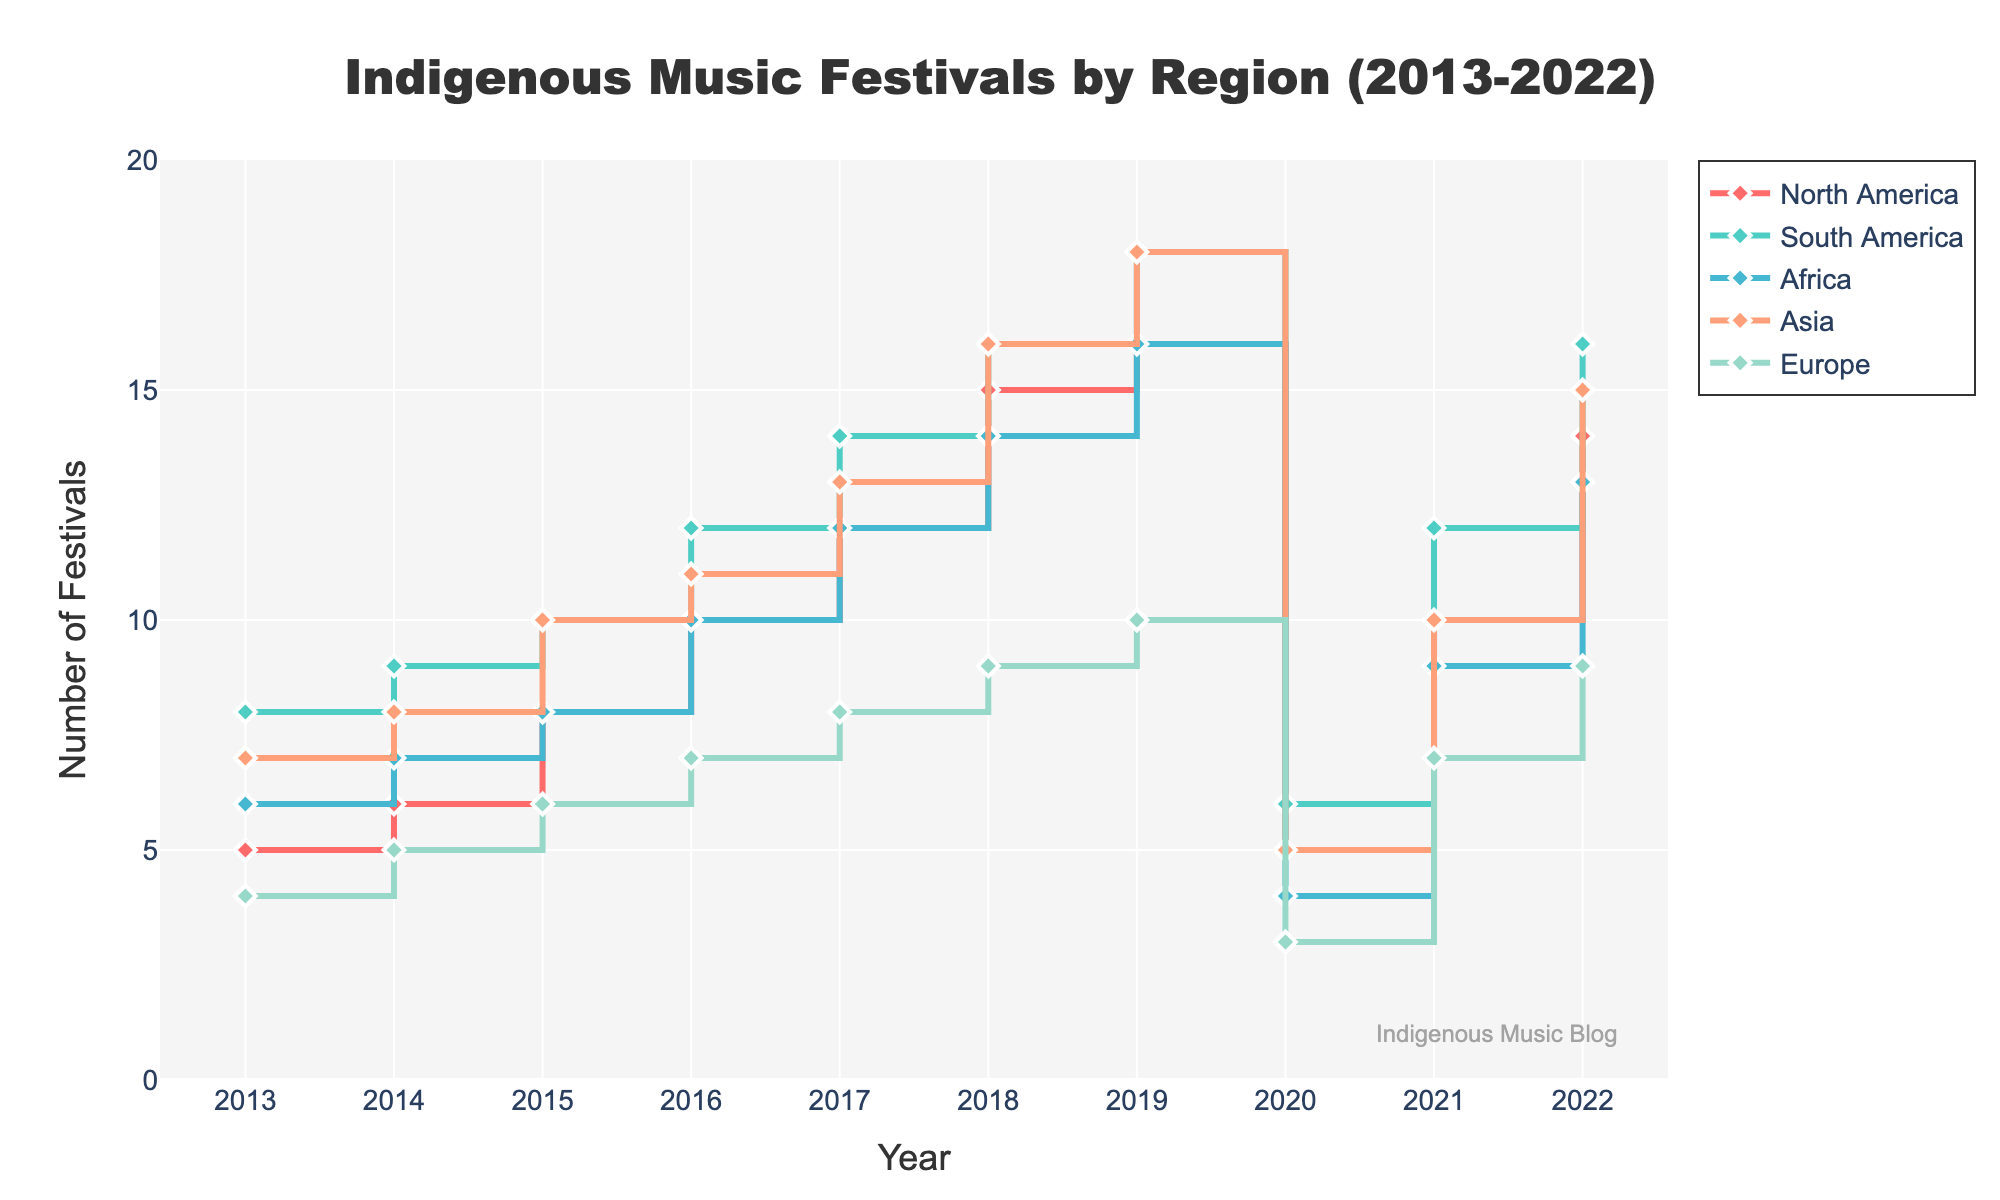Which region had the highest number of festivals in 2022? Look at the year 2022 on the x-axis and identify the highest point on the y-axis among all regions. South America reaches the highest value at 16 festivals.
Answer: South America How many festivals were held in Europe in 2020? Locate the year 2020 on the x-axis and check the corresponding value for the Europe region on the y-axis. The data point for Europe reads 3 festivals.
Answer: 3 What trend can be observed in the number of festivals in Asia from 2013 to 2019? Observe the data points for Asia from 2013 to 2019, where there is a general upward trend until it dips in 2020. Festivals increase from 7 (2013) to 18 (2019).
Answer: Increasing trend How did the number of festivals in Africa change from 2016 to 2018? Look at the data points for Africa between 2016 and 2018 to see the change. It increases from 10 (2016) to 14 (2018).
Answer: Increased What impact did 2020 have on the frequency of festivals in the regions? Check the data points in 2020 for all regions and compare them with previous and subsequent years; all regions show a significant decline in 2020.
Answer: Decline Which region showed the most rapid growth in the number of festivals from 2013 to 2019? Calculate the difference in the number of festivals between 2013 and 2019 for all regions and identify the region with the largest positive change. South America shows the largest growth (from 8 to 18).
Answer: South America What is the average number of festivals in North America for the years provided? Sum the number of festivals in North America from 2013 to 2022 and divide by the number of years (10). Calculation: (5+6+8+10+12+15+16+5+10+14)/10 = 10.1.
Answer: 10.1 Did any region have a consistent increase in the number of festivals every year from 2013 to 2019? Review each region's data points from 2013 to 2019 for a consistent yearly increase. South America has a steady increase every year from 8 (2013) to 18 (2019).
Answer: South America In which year did North America have its sharpest decline in the number of festivals? Compare consecutive years for North America and observe the largest drop. The sharpest decline is between 2019 (16) and 2020 (5).
Answer: 2020 